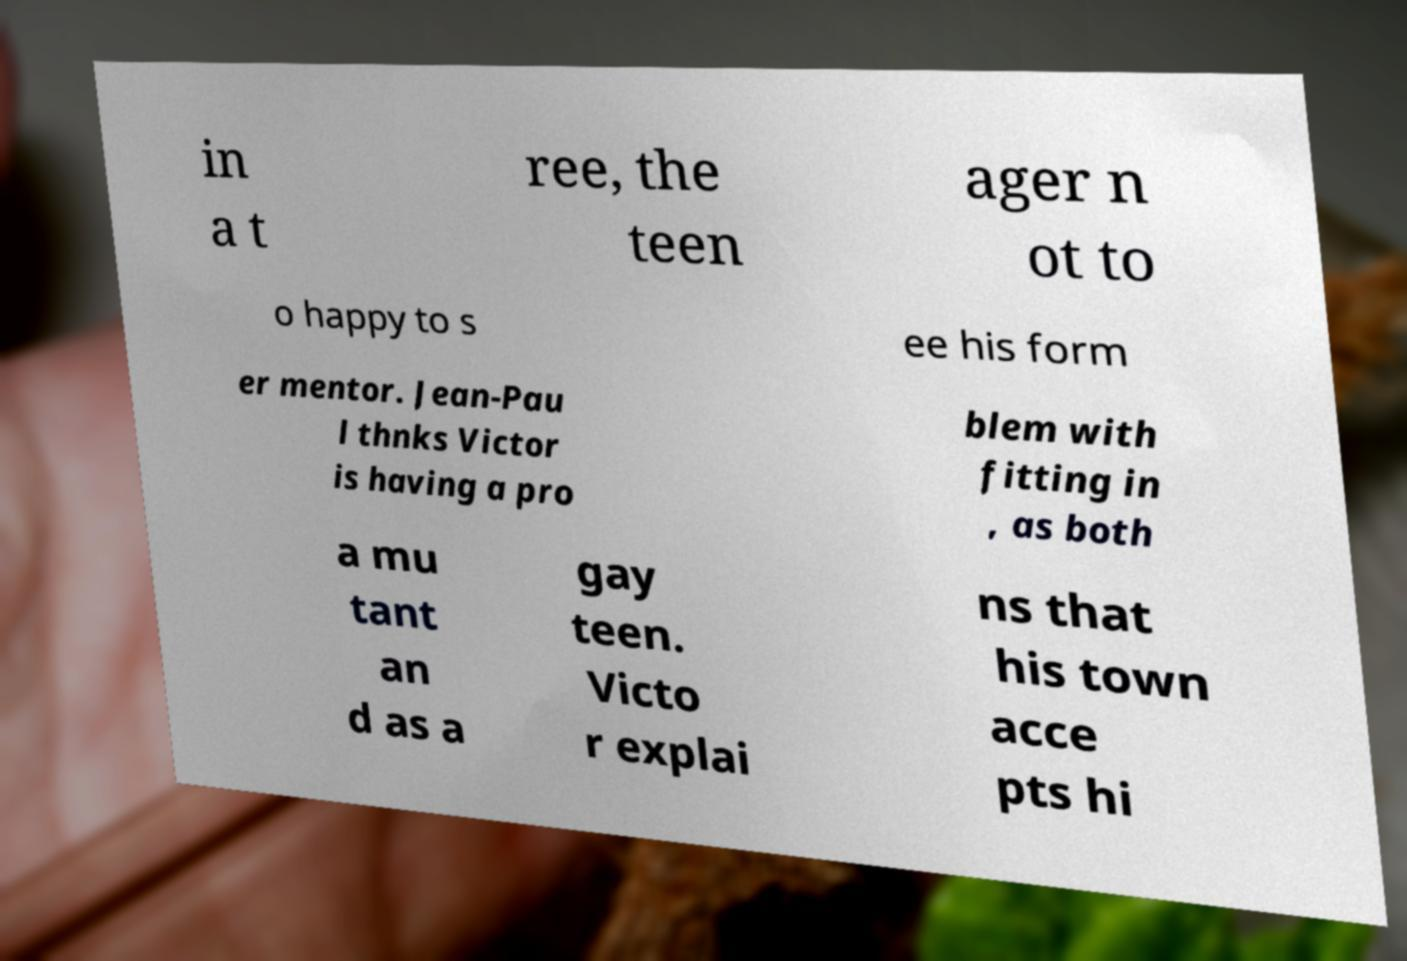Please read and relay the text visible in this image. What does it say? in a t ree, the teen ager n ot to o happy to s ee his form er mentor. Jean-Pau l thnks Victor is having a pro blem with fitting in , as both a mu tant an d as a gay teen. Victo r explai ns that his town acce pts hi 